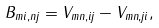Convert formula to latex. <formula><loc_0><loc_0><loc_500><loc_500>B _ { m i , n j } = V _ { m n , i j } - V _ { m n , j i } ,</formula> 